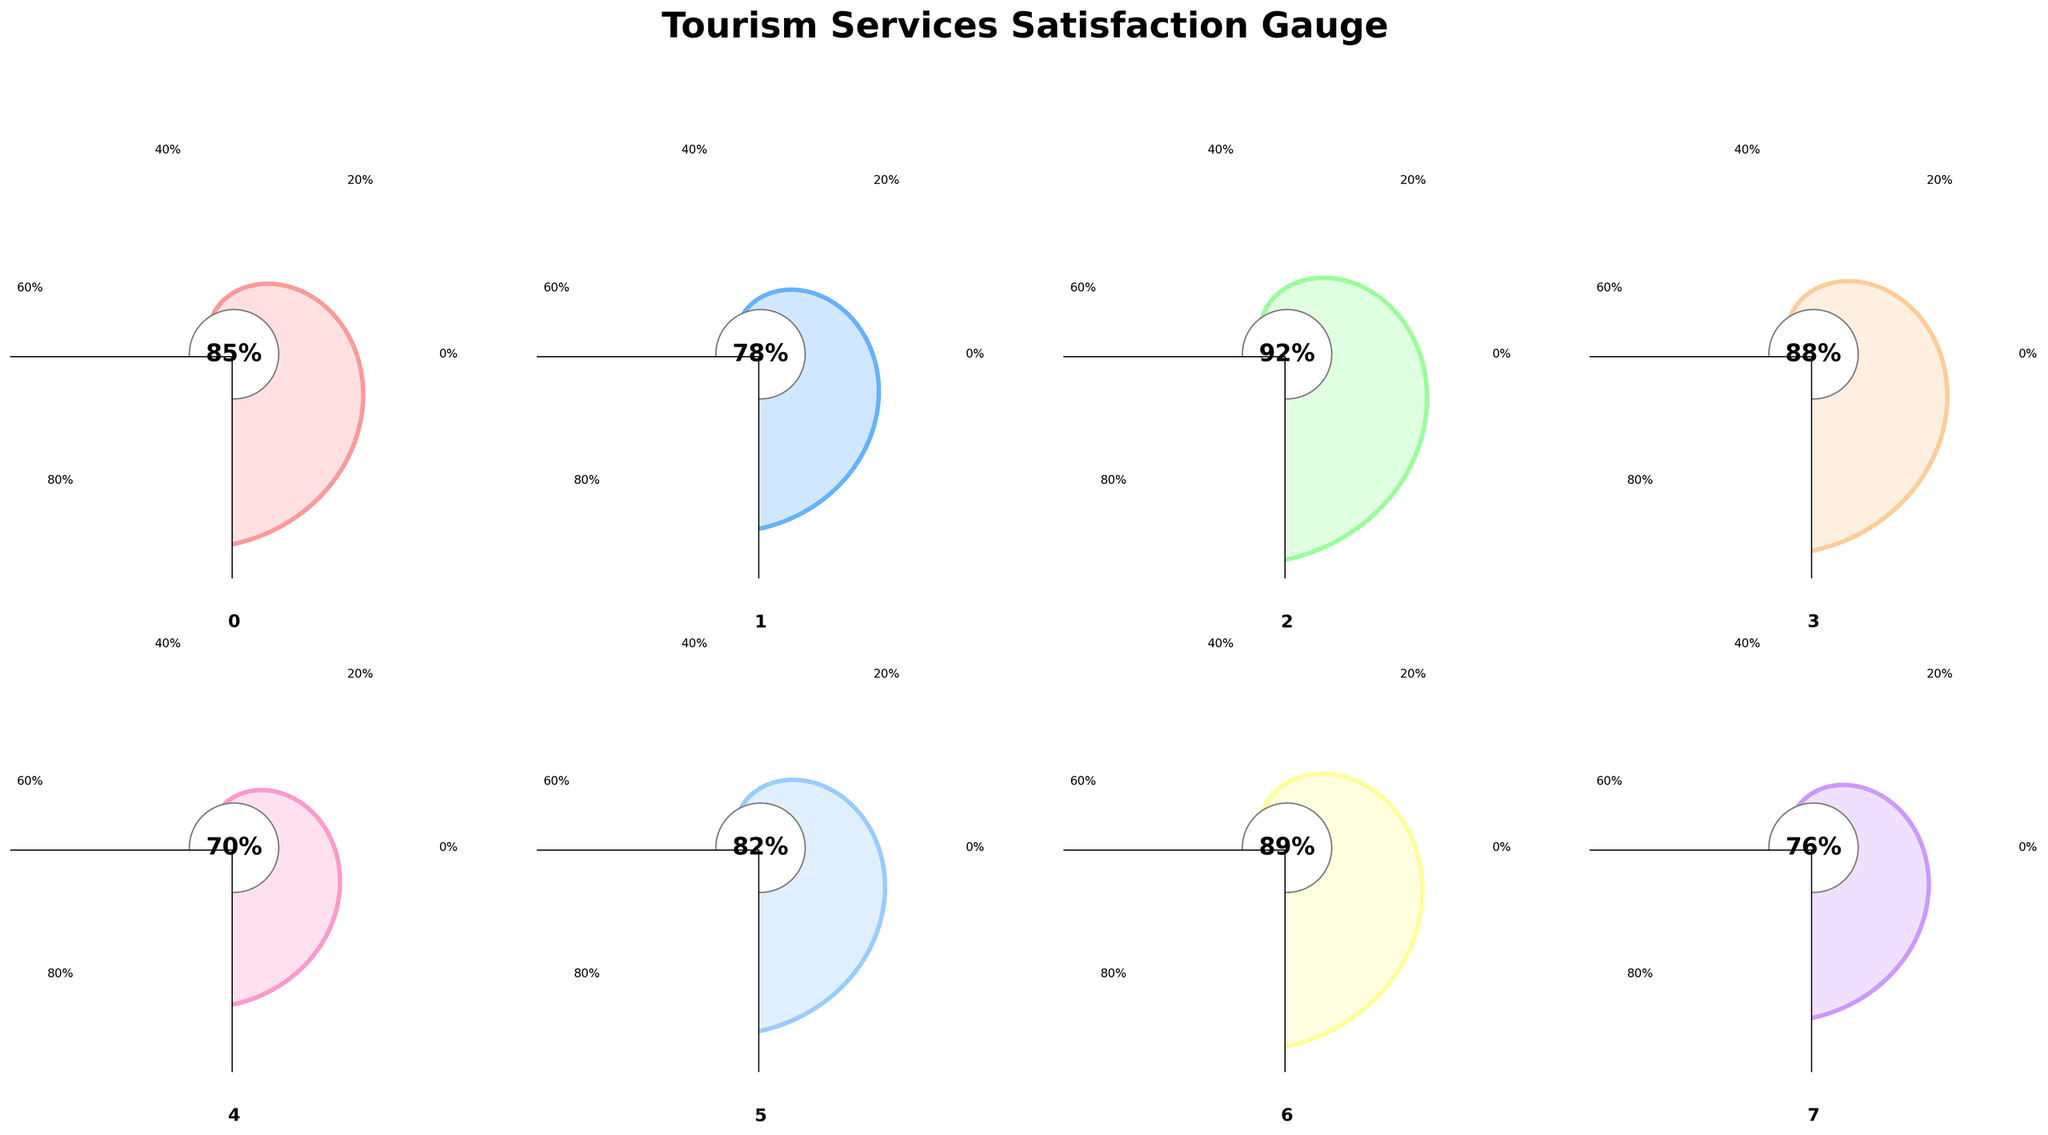What is the highest customer satisfaction rating among the aspects of tourism services? The highest rating can be identified by looking at the figure and finding the gauge with the highest percentage displayed. It shows "Local Cuisine" with 92%.
Answer: 92% Which aspect has the lowest customer satisfaction rating? By examining the plot, "Transportation Services" has the lowest rating at 70%.
Answer: 70% How many aspects have a satisfaction rating of 80% or higher? Looking at the satisfaction percentages in the figure, the aspects with 80% or higher are "Overall Experience", "Local Cuisine", "Heritage Site Tours", "Retail Shopping", and "Hospitality Staff". There are 5 aspects in total.
Answer: 5 What is the difference in satisfaction rating between "Accommodation Quality" and "Value for Money"? The satisfaction rating for "Accommodation Quality" is 78%, and for "Value for Money" it's 76%. The difference is 78% - 76% = 2%.
Answer: 2% Which aspect has a satisfaction rating closest to the overall experience rating? The rating for "Overall Experience" is 85%. "Heritage Site Tours" has a rating of 88%, and "Hospitality Staff" has a rating of 89%, which are the closest.
Answer: Heritage Site Tours (88%) Is the satisfaction rating for "Retail Shopping" higher or lower than "Accommodation Quality"? The satisfaction rating for "Retail Shopping" is 82%, while "Accommodation Quality" is 78%. Thus, "Retail Shopping" is higher.
Answer: Higher Is the median satisfaction rating for these aspects higher or lower than 80%? The ratings are (85, 78, 92, 88, 70, 82, 89, 76). Ordered, they are (70, 76, 78, 82, 85, 88, 89, 92). The median is the average of the 4th and 5th values: (82 + 85)/2 = 83.5%, which is higher than 80%.
Answer: Higher What is the total sum of the satisfaction ratings for all aspects? Adding all the ratings: 85 + 78 + 92 + 88 + 70 + 82 + 89 + 76 = 660.
Answer: 660 Which aspect has a rating that is 12% higher than "Value for Money"? "Value for Money" has a rating of 76%, adding 12% gives 88%, which corresponds to "Heritage Site Tours".
Answer: Heritage Site Tours (88%) Are there more aspects with a rating higher than 80% compared to those with a rating lower than 80%? Aspects with ratings higher than 80% are "Overall Experience", "Local Cuisine", "Heritage Site Tours", "Retail Shopping", "Hospitality Staff" (5 aspects). Aspects with ratings lower than 80% are "Accommodation Quality", "Transportation Services", and "Value for Money" (3 aspects). Yes, there are more aspects with a rating higher than 80%.
Answer: Yes 